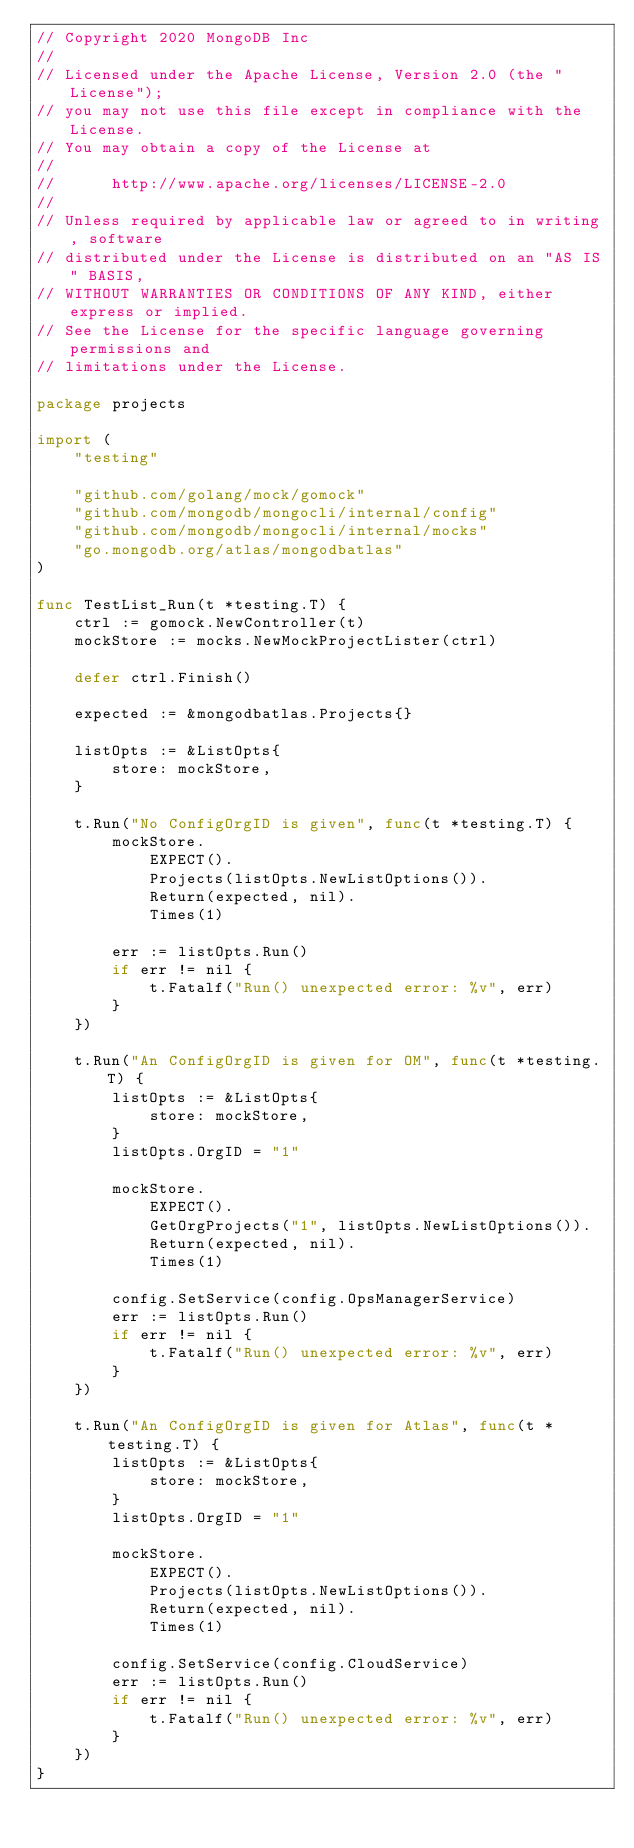<code> <loc_0><loc_0><loc_500><loc_500><_Go_>// Copyright 2020 MongoDB Inc
//
// Licensed under the Apache License, Version 2.0 (the "License");
// you may not use this file except in compliance with the License.
// You may obtain a copy of the License at
//
//      http://www.apache.org/licenses/LICENSE-2.0
//
// Unless required by applicable law or agreed to in writing, software
// distributed under the License is distributed on an "AS IS" BASIS,
// WITHOUT WARRANTIES OR CONDITIONS OF ANY KIND, either express or implied.
// See the License for the specific language governing permissions and
// limitations under the License.

package projects

import (
	"testing"

	"github.com/golang/mock/gomock"
	"github.com/mongodb/mongocli/internal/config"
	"github.com/mongodb/mongocli/internal/mocks"
	"go.mongodb.org/atlas/mongodbatlas"
)

func TestList_Run(t *testing.T) {
	ctrl := gomock.NewController(t)
	mockStore := mocks.NewMockProjectLister(ctrl)

	defer ctrl.Finish()

	expected := &mongodbatlas.Projects{}

	listOpts := &ListOpts{
		store: mockStore,
	}

	t.Run("No ConfigOrgID is given", func(t *testing.T) {
		mockStore.
			EXPECT().
			Projects(listOpts.NewListOptions()).
			Return(expected, nil).
			Times(1)

		err := listOpts.Run()
		if err != nil {
			t.Fatalf("Run() unexpected error: %v", err)
		}
	})

	t.Run("An ConfigOrgID is given for OM", func(t *testing.T) {
		listOpts := &ListOpts{
			store: mockStore,
		}
		listOpts.OrgID = "1"

		mockStore.
			EXPECT().
			GetOrgProjects("1", listOpts.NewListOptions()).
			Return(expected, nil).
			Times(1)

		config.SetService(config.OpsManagerService)
		err := listOpts.Run()
		if err != nil {
			t.Fatalf("Run() unexpected error: %v", err)
		}
	})

	t.Run("An ConfigOrgID is given for Atlas", func(t *testing.T) {
		listOpts := &ListOpts{
			store: mockStore,
		}
		listOpts.OrgID = "1"

		mockStore.
			EXPECT().
			Projects(listOpts.NewListOptions()).
			Return(expected, nil).
			Times(1)

		config.SetService(config.CloudService)
		err := listOpts.Run()
		if err != nil {
			t.Fatalf("Run() unexpected error: %v", err)
		}
	})
}
</code> 